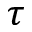Convert formula to latex. <formula><loc_0><loc_0><loc_500><loc_500>\tau</formula> 